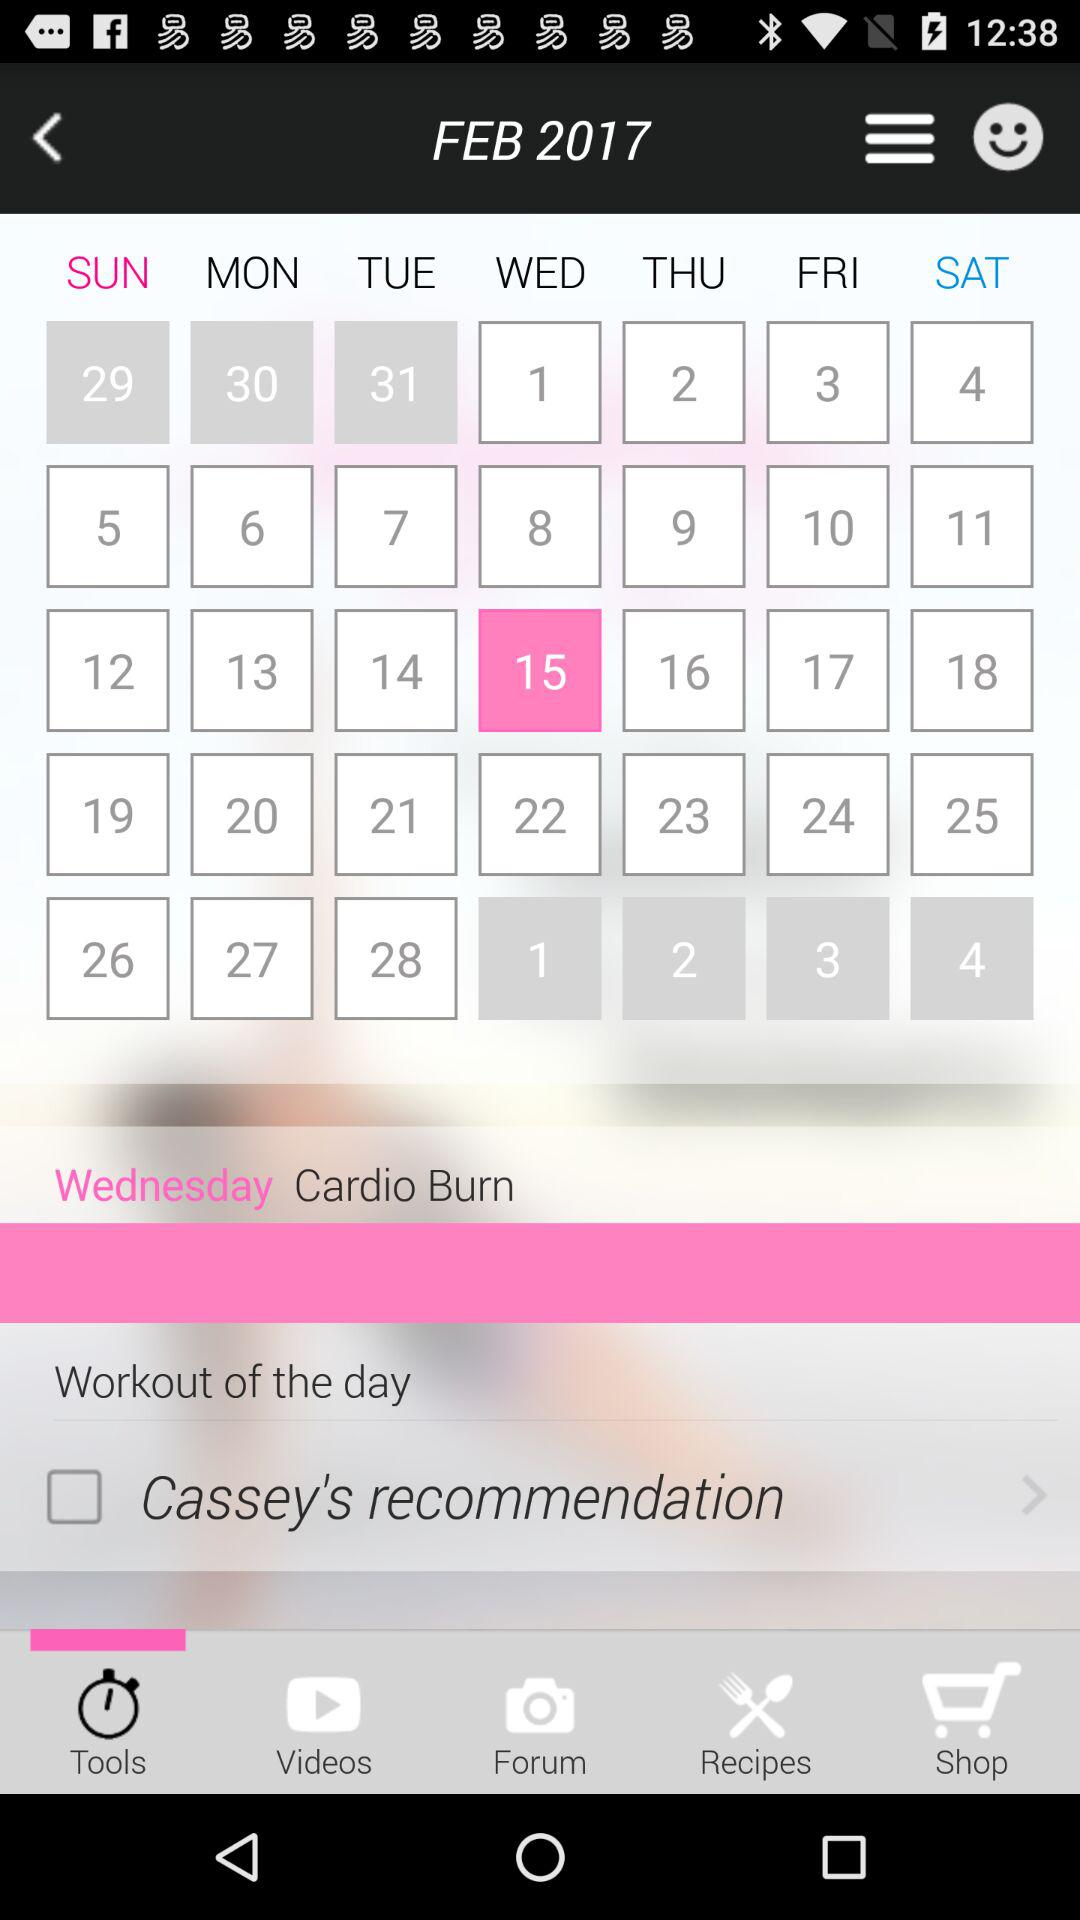Which tab is open? The open tab is "Tools". 